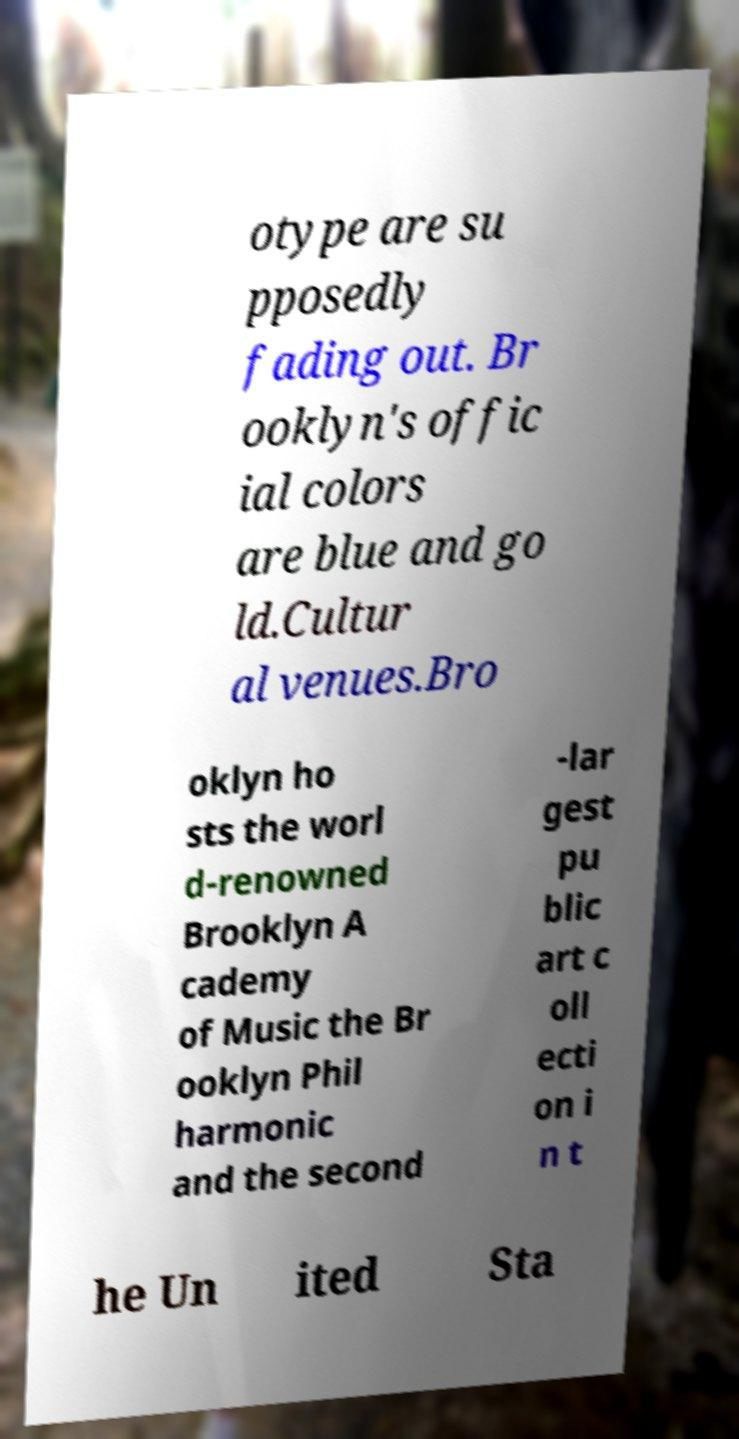Please read and relay the text visible in this image. What does it say? otype are su pposedly fading out. Br ooklyn's offic ial colors are blue and go ld.Cultur al venues.Bro oklyn ho sts the worl d-renowned Brooklyn A cademy of Music the Br ooklyn Phil harmonic and the second -lar gest pu blic art c oll ecti on i n t he Un ited Sta 